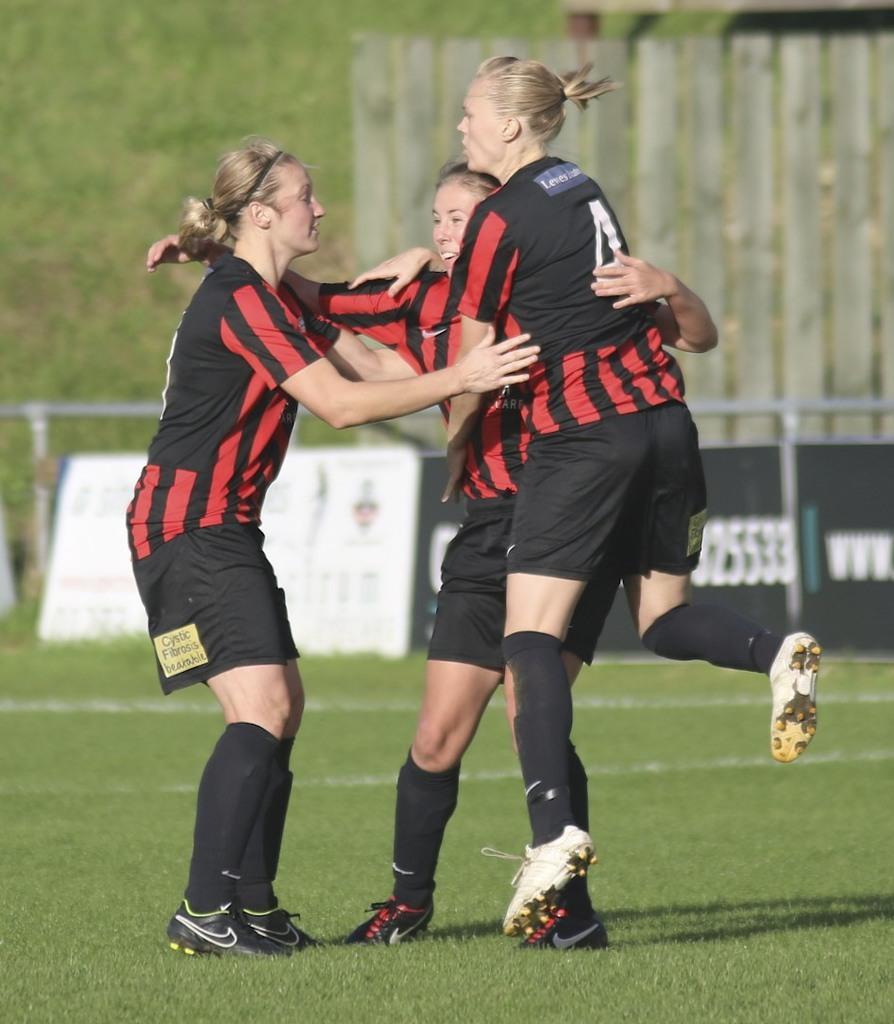Can you describe this image briefly? This picture is clicked outside. On the right we can see a person wearing t-shirt and seems to be jumping in the air and we can see the two persons wearing red color t-shirts and standing on the ground and we can see the green grass. In the background we can see the metal rods and the text and numbers on a black color object seems to be the banner and we can see the wooden planks and some other objects. 